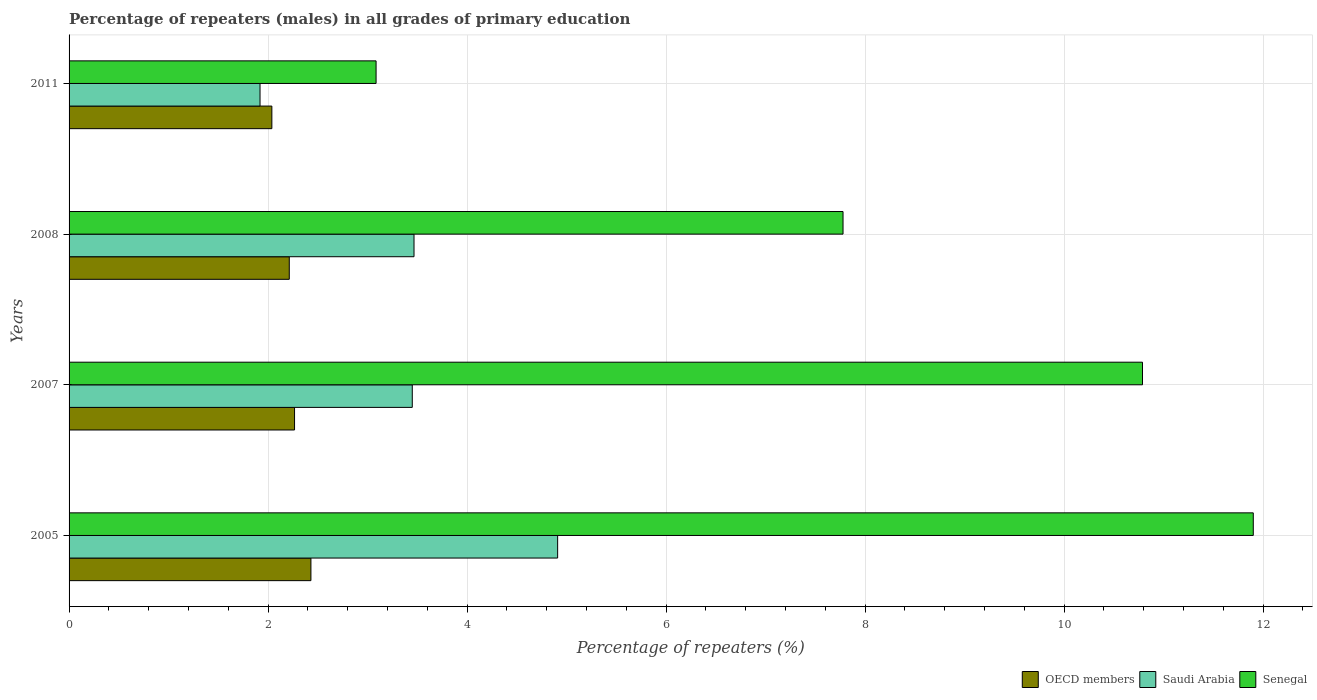How many different coloured bars are there?
Offer a terse response. 3. How many groups of bars are there?
Keep it short and to the point. 4. Are the number of bars per tick equal to the number of legend labels?
Give a very brief answer. Yes. Are the number of bars on each tick of the Y-axis equal?
Give a very brief answer. Yes. In how many cases, is the number of bars for a given year not equal to the number of legend labels?
Keep it short and to the point. 0. What is the percentage of repeaters (males) in Senegal in 2007?
Keep it short and to the point. 10.79. Across all years, what is the maximum percentage of repeaters (males) in Saudi Arabia?
Make the answer very short. 4.91. Across all years, what is the minimum percentage of repeaters (males) in Senegal?
Ensure brevity in your answer.  3.09. What is the total percentage of repeaters (males) in OECD members in the graph?
Make the answer very short. 8.95. What is the difference between the percentage of repeaters (males) in Senegal in 2005 and that in 2008?
Your response must be concise. 4.12. What is the difference between the percentage of repeaters (males) in Saudi Arabia in 2011 and the percentage of repeaters (males) in Senegal in 2007?
Give a very brief answer. -8.87. What is the average percentage of repeaters (males) in OECD members per year?
Offer a terse response. 2.24. In the year 2011, what is the difference between the percentage of repeaters (males) in Senegal and percentage of repeaters (males) in OECD members?
Offer a terse response. 1.05. What is the ratio of the percentage of repeaters (males) in Saudi Arabia in 2005 to that in 2007?
Keep it short and to the point. 1.42. What is the difference between the highest and the second highest percentage of repeaters (males) in Saudi Arabia?
Your answer should be compact. 1.44. What is the difference between the highest and the lowest percentage of repeaters (males) in OECD members?
Offer a terse response. 0.39. In how many years, is the percentage of repeaters (males) in Senegal greater than the average percentage of repeaters (males) in Senegal taken over all years?
Offer a very short reply. 2. Is the sum of the percentage of repeaters (males) in Senegal in 2005 and 2011 greater than the maximum percentage of repeaters (males) in Saudi Arabia across all years?
Your response must be concise. Yes. What does the 1st bar from the top in 2007 represents?
Provide a short and direct response. Senegal. What does the 3rd bar from the bottom in 2008 represents?
Offer a very short reply. Senegal. Is it the case that in every year, the sum of the percentage of repeaters (males) in Saudi Arabia and percentage of repeaters (males) in OECD members is greater than the percentage of repeaters (males) in Senegal?
Offer a terse response. No. How many bars are there?
Your answer should be very brief. 12. Are all the bars in the graph horizontal?
Make the answer very short. Yes. How many years are there in the graph?
Ensure brevity in your answer.  4. Are the values on the major ticks of X-axis written in scientific E-notation?
Offer a terse response. No. Does the graph contain any zero values?
Your answer should be compact. No. Does the graph contain grids?
Provide a short and direct response. Yes. Where does the legend appear in the graph?
Give a very brief answer. Bottom right. What is the title of the graph?
Your answer should be compact. Percentage of repeaters (males) in all grades of primary education. Does "Sub-Saharan Africa (all income levels)" appear as one of the legend labels in the graph?
Your answer should be compact. No. What is the label or title of the X-axis?
Ensure brevity in your answer.  Percentage of repeaters (%). What is the label or title of the Y-axis?
Your response must be concise. Years. What is the Percentage of repeaters (%) in OECD members in 2005?
Make the answer very short. 2.43. What is the Percentage of repeaters (%) in Saudi Arabia in 2005?
Keep it short and to the point. 4.91. What is the Percentage of repeaters (%) of Senegal in 2005?
Your answer should be compact. 11.9. What is the Percentage of repeaters (%) of OECD members in 2007?
Provide a succinct answer. 2.27. What is the Percentage of repeaters (%) in Saudi Arabia in 2007?
Your response must be concise. 3.45. What is the Percentage of repeaters (%) of Senegal in 2007?
Keep it short and to the point. 10.79. What is the Percentage of repeaters (%) in OECD members in 2008?
Your answer should be compact. 2.21. What is the Percentage of repeaters (%) in Saudi Arabia in 2008?
Give a very brief answer. 3.47. What is the Percentage of repeaters (%) of Senegal in 2008?
Offer a terse response. 7.78. What is the Percentage of repeaters (%) in OECD members in 2011?
Your answer should be compact. 2.04. What is the Percentage of repeaters (%) in Saudi Arabia in 2011?
Keep it short and to the point. 1.92. What is the Percentage of repeaters (%) of Senegal in 2011?
Keep it short and to the point. 3.09. Across all years, what is the maximum Percentage of repeaters (%) in OECD members?
Keep it short and to the point. 2.43. Across all years, what is the maximum Percentage of repeaters (%) in Saudi Arabia?
Offer a terse response. 4.91. Across all years, what is the maximum Percentage of repeaters (%) of Senegal?
Offer a terse response. 11.9. Across all years, what is the minimum Percentage of repeaters (%) of OECD members?
Provide a succinct answer. 2.04. Across all years, what is the minimum Percentage of repeaters (%) in Saudi Arabia?
Your answer should be very brief. 1.92. Across all years, what is the minimum Percentage of repeaters (%) in Senegal?
Provide a succinct answer. 3.09. What is the total Percentage of repeaters (%) of OECD members in the graph?
Keep it short and to the point. 8.95. What is the total Percentage of repeaters (%) of Saudi Arabia in the graph?
Your answer should be very brief. 13.75. What is the total Percentage of repeaters (%) in Senegal in the graph?
Your response must be concise. 33.56. What is the difference between the Percentage of repeaters (%) of OECD members in 2005 and that in 2007?
Provide a succinct answer. 0.16. What is the difference between the Percentage of repeaters (%) in Saudi Arabia in 2005 and that in 2007?
Make the answer very short. 1.46. What is the difference between the Percentage of repeaters (%) in Senegal in 2005 and that in 2007?
Provide a succinct answer. 1.11. What is the difference between the Percentage of repeaters (%) of OECD members in 2005 and that in 2008?
Offer a terse response. 0.22. What is the difference between the Percentage of repeaters (%) in Saudi Arabia in 2005 and that in 2008?
Provide a short and direct response. 1.44. What is the difference between the Percentage of repeaters (%) of Senegal in 2005 and that in 2008?
Keep it short and to the point. 4.12. What is the difference between the Percentage of repeaters (%) in OECD members in 2005 and that in 2011?
Your response must be concise. 0.39. What is the difference between the Percentage of repeaters (%) in Saudi Arabia in 2005 and that in 2011?
Ensure brevity in your answer.  2.99. What is the difference between the Percentage of repeaters (%) in Senegal in 2005 and that in 2011?
Provide a succinct answer. 8.82. What is the difference between the Percentage of repeaters (%) of OECD members in 2007 and that in 2008?
Offer a very short reply. 0.05. What is the difference between the Percentage of repeaters (%) of Saudi Arabia in 2007 and that in 2008?
Make the answer very short. -0.02. What is the difference between the Percentage of repeaters (%) in Senegal in 2007 and that in 2008?
Make the answer very short. 3.01. What is the difference between the Percentage of repeaters (%) in OECD members in 2007 and that in 2011?
Your response must be concise. 0.23. What is the difference between the Percentage of repeaters (%) in Saudi Arabia in 2007 and that in 2011?
Provide a short and direct response. 1.53. What is the difference between the Percentage of repeaters (%) of Senegal in 2007 and that in 2011?
Give a very brief answer. 7.7. What is the difference between the Percentage of repeaters (%) of OECD members in 2008 and that in 2011?
Your answer should be compact. 0.18. What is the difference between the Percentage of repeaters (%) in Saudi Arabia in 2008 and that in 2011?
Your response must be concise. 1.55. What is the difference between the Percentage of repeaters (%) in Senegal in 2008 and that in 2011?
Provide a succinct answer. 4.69. What is the difference between the Percentage of repeaters (%) in OECD members in 2005 and the Percentage of repeaters (%) in Saudi Arabia in 2007?
Make the answer very short. -1.02. What is the difference between the Percentage of repeaters (%) in OECD members in 2005 and the Percentage of repeaters (%) in Senegal in 2007?
Keep it short and to the point. -8.36. What is the difference between the Percentage of repeaters (%) in Saudi Arabia in 2005 and the Percentage of repeaters (%) in Senegal in 2007?
Your answer should be very brief. -5.88. What is the difference between the Percentage of repeaters (%) in OECD members in 2005 and the Percentage of repeaters (%) in Saudi Arabia in 2008?
Ensure brevity in your answer.  -1.04. What is the difference between the Percentage of repeaters (%) of OECD members in 2005 and the Percentage of repeaters (%) of Senegal in 2008?
Offer a very short reply. -5.35. What is the difference between the Percentage of repeaters (%) of Saudi Arabia in 2005 and the Percentage of repeaters (%) of Senegal in 2008?
Offer a terse response. -2.87. What is the difference between the Percentage of repeaters (%) of OECD members in 2005 and the Percentage of repeaters (%) of Saudi Arabia in 2011?
Provide a short and direct response. 0.51. What is the difference between the Percentage of repeaters (%) of OECD members in 2005 and the Percentage of repeaters (%) of Senegal in 2011?
Your answer should be very brief. -0.65. What is the difference between the Percentage of repeaters (%) of Saudi Arabia in 2005 and the Percentage of repeaters (%) of Senegal in 2011?
Keep it short and to the point. 1.82. What is the difference between the Percentage of repeaters (%) in OECD members in 2007 and the Percentage of repeaters (%) in Saudi Arabia in 2008?
Your answer should be compact. -1.2. What is the difference between the Percentage of repeaters (%) of OECD members in 2007 and the Percentage of repeaters (%) of Senegal in 2008?
Make the answer very short. -5.51. What is the difference between the Percentage of repeaters (%) of Saudi Arabia in 2007 and the Percentage of repeaters (%) of Senegal in 2008?
Keep it short and to the point. -4.33. What is the difference between the Percentage of repeaters (%) of OECD members in 2007 and the Percentage of repeaters (%) of Saudi Arabia in 2011?
Make the answer very short. 0.35. What is the difference between the Percentage of repeaters (%) in OECD members in 2007 and the Percentage of repeaters (%) in Senegal in 2011?
Provide a succinct answer. -0.82. What is the difference between the Percentage of repeaters (%) of Saudi Arabia in 2007 and the Percentage of repeaters (%) of Senegal in 2011?
Provide a short and direct response. 0.36. What is the difference between the Percentage of repeaters (%) in OECD members in 2008 and the Percentage of repeaters (%) in Saudi Arabia in 2011?
Give a very brief answer. 0.29. What is the difference between the Percentage of repeaters (%) of OECD members in 2008 and the Percentage of repeaters (%) of Senegal in 2011?
Your answer should be compact. -0.87. What is the difference between the Percentage of repeaters (%) in Saudi Arabia in 2008 and the Percentage of repeaters (%) in Senegal in 2011?
Give a very brief answer. 0.38. What is the average Percentage of repeaters (%) in OECD members per year?
Make the answer very short. 2.24. What is the average Percentage of repeaters (%) in Saudi Arabia per year?
Your answer should be compact. 3.44. What is the average Percentage of repeaters (%) in Senegal per year?
Make the answer very short. 8.39. In the year 2005, what is the difference between the Percentage of repeaters (%) of OECD members and Percentage of repeaters (%) of Saudi Arabia?
Your answer should be compact. -2.48. In the year 2005, what is the difference between the Percentage of repeaters (%) in OECD members and Percentage of repeaters (%) in Senegal?
Provide a short and direct response. -9.47. In the year 2005, what is the difference between the Percentage of repeaters (%) in Saudi Arabia and Percentage of repeaters (%) in Senegal?
Give a very brief answer. -6.99. In the year 2007, what is the difference between the Percentage of repeaters (%) in OECD members and Percentage of repeaters (%) in Saudi Arabia?
Give a very brief answer. -1.18. In the year 2007, what is the difference between the Percentage of repeaters (%) in OECD members and Percentage of repeaters (%) in Senegal?
Offer a very short reply. -8.52. In the year 2007, what is the difference between the Percentage of repeaters (%) in Saudi Arabia and Percentage of repeaters (%) in Senegal?
Provide a short and direct response. -7.34. In the year 2008, what is the difference between the Percentage of repeaters (%) in OECD members and Percentage of repeaters (%) in Saudi Arabia?
Your answer should be very brief. -1.25. In the year 2008, what is the difference between the Percentage of repeaters (%) in OECD members and Percentage of repeaters (%) in Senegal?
Keep it short and to the point. -5.57. In the year 2008, what is the difference between the Percentage of repeaters (%) in Saudi Arabia and Percentage of repeaters (%) in Senegal?
Ensure brevity in your answer.  -4.31. In the year 2011, what is the difference between the Percentage of repeaters (%) in OECD members and Percentage of repeaters (%) in Saudi Arabia?
Provide a short and direct response. 0.12. In the year 2011, what is the difference between the Percentage of repeaters (%) of OECD members and Percentage of repeaters (%) of Senegal?
Your response must be concise. -1.05. In the year 2011, what is the difference between the Percentage of repeaters (%) of Saudi Arabia and Percentage of repeaters (%) of Senegal?
Your response must be concise. -1.17. What is the ratio of the Percentage of repeaters (%) of OECD members in 2005 to that in 2007?
Keep it short and to the point. 1.07. What is the ratio of the Percentage of repeaters (%) in Saudi Arabia in 2005 to that in 2007?
Provide a succinct answer. 1.42. What is the ratio of the Percentage of repeaters (%) of Senegal in 2005 to that in 2007?
Offer a very short reply. 1.1. What is the ratio of the Percentage of repeaters (%) of OECD members in 2005 to that in 2008?
Keep it short and to the point. 1.1. What is the ratio of the Percentage of repeaters (%) of Saudi Arabia in 2005 to that in 2008?
Your response must be concise. 1.42. What is the ratio of the Percentage of repeaters (%) of Senegal in 2005 to that in 2008?
Your response must be concise. 1.53. What is the ratio of the Percentage of repeaters (%) of OECD members in 2005 to that in 2011?
Give a very brief answer. 1.19. What is the ratio of the Percentage of repeaters (%) in Saudi Arabia in 2005 to that in 2011?
Your answer should be compact. 2.56. What is the ratio of the Percentage of repeaters (%) in Senegal in 2005 to that in 2011?
Your answer should be very brief. 3.86. What is the ratio of the Percentage of repeaters (%) of OECD members in 2007 to that in 2008?
Your answer should be compact. 1.02. What is the ratio of the Percentage of repeaters (%) in Senegal in 2007 to that in 2008?
Your response must be concise. 1.39. What is the ratio of the Percentage of repeaters (%) in OECD members in 2007 to that in 2011?
Provide a succinct answer. 1.11. What is the ratio of the Percentage of repeaters (%) of Saudi Arabia in 2007 to that in 2011?
Give a very brief answer. 1.8. What is the ratio of the Percentage of repeaters (%) in Senegal in 2007 to that in 2011?
Provide a short and direct response. 3.5. What is the ratio of the Percentage of repeaters (%) of OECD members in 2008 to that in 2011?
Give a very brief answer. 1.09. What is the ratio of the Percentage of repeaters (%) of Saudi Arabia in 2008 to that in 2011?
Your answer should be compact. 1.81. What is the ratio of the Percentage of repeaters (%) of Senegal in 2008 to that in 2011?
Provide a succinct answer. 2.52. What is the difference between the highest and the second highest Percentage of repeaters (%) of OECD members?
Offer a terse response. 0.16. What is the difference between the highest and the second highest Percentage of repeaters (%) of Saudi Arabia?
Keep it short and to the point. 1.44. What is the difference between the highest and the second highest Percentage of repeaters (%) in Senegal?
Your answer should be compact. 1.11. What is the difference between the highest and the lowest Percentage of repeaters (%) of OECD members?
Your answer should be very brief. 0.39. What is the difference between the highest and the lowest Percentage of repeaters (%) in Saudi Arabia?
Provide a short and direct response. 2.99. What is the difference between the highest and the lowest Percentage of repeaters (%) in Senegal?
Provide a succinct answer. 8.82. 